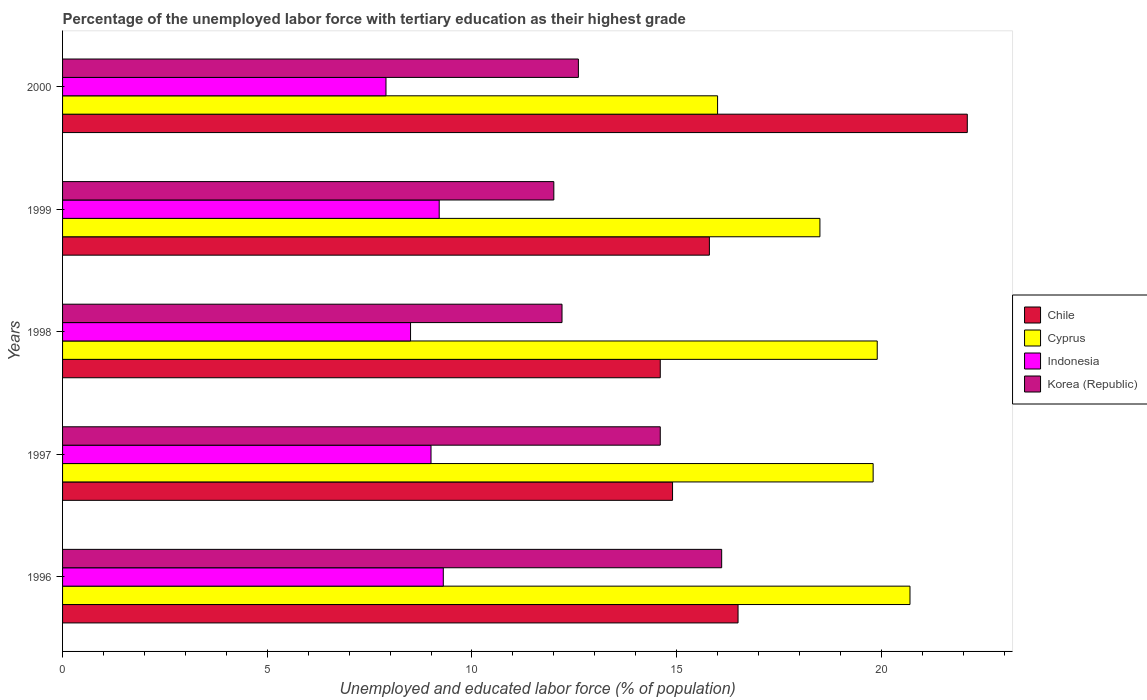How many different coloured bars are there?
Your response must be concise. 4. Are the number of bars per tick equal to the number of legend labels?
Offer a terse response. Yes. Are the number of bars on each tick of the Y-axis equal?
Offer a very short reply. Yes. How many bars are there on the 5th tick from the top?
Your answer should be compact. 4. In how many cases, is the number of bars for a given year not equal to the number of legend labels?
Offer a very short reply. 0. What is the percentage of the unemployed labor force with tertiary education in Cyprus in 1998?
Offer a very short reply. 19.9. Across all years, what is the maximum percentage of the unemployed labor force with tertiary education in Korea (Republic)?
Ensure brevity in your answer.  16.1. In which year was the percentage of the unemployed labor force with tertiary education in Korea (Republic) maximum?
Give a very brief answer. 1996. What is the total percentage of the unemployed labor force with tertiary education in Korea (Republic) in the graph?
Your answer should be very brief. 67.5. What is the difference between the percentage of the unemployed labor force with tertiary education in Indonesia in 1996 and that in 1997?
Ensure brevity in your answer.  0.3. What is the difference between the percentage of the unemployed labor force with tertiary education in Indonesia in 2000 and the percentage of the unemployed labor force with tertiary education in Chile in 1997?
Offer a terse response. -7. What is the average percentage of the unemployed labor force with tertiary education in Cyprus per year?
Keep it short and to the point. 18.98. In the year 1998, what is the difference between the percentage of the unemployed labor force with tertiary education in Korea (Republic) and percentage of the unemployed labor force with tertiary education in Chile?
Ensure brevity in your answer.  -2.4. In how many years, is the percentage of the unemployed labor force with tertiary education in Chile greater than 2 %?
Your answer should be very brief. 5. What is the ratio of the percentage of the unemployed labor force with tertiary education in Korea (Republic) in 1997 to that in 2000?
Your answer should be very brief. 1.16. Is the percentage of the unemployed labor force with tertiary education in Chile in 1996 less than that in 1999?
Make the answer very short. No. Is the difference between the percentage of the unemployed labor force with tertiary education in Korea (Republic) in 1996 and 2000 greater than the difference between the percentage of the unemployed labor force with tertiary education in Chile in 1996 and 2000?
Give a very brief answer. Yes. What is the difference between the highest and the second highest percentage of the unemployed labor force with tertiary education in Cyprus?
Make the answer very short. 0.8. What is the difference between the highest and the lowest percentage of the unemployed labor force with tertiary education in Korea (Republic)?
Your response must be concise. 4.1. In how many years, is the percentage of the unemployed labor force with tertiary education in Cyprus greater than the average percentage of the unemployed labor force with tertiary education in Cyprus taken over all years?
Offer a terse response. 3. Is the sum of the percentage of the unemployed labor force with tertiary education in Indonesia in 1999 and 2000 greater than the maximum percentage of the unemployed labor force with tertiary education in Korea (Republic) across all years?
Provide a short and direct response. Yes. Is it the case that in every year, the sum of the percentage of the unemployed labor force with tertiary education in Korea (Republic) and percentage of the unemployed labor force with tertiary education in Chile is greater than the sum of percentage of the unemployed labor force with tertiary education in Indonesia and percentage of the unemployed labor force with tertiary education in Cyprus?
Your answer should be compact. No. Is it the case that in every year, the sum of the percentage of the unemployed labor force with tertiary education in Chile and percentage of the unemployed labor force with tertiary education in Korea (Republic) is greater than the percentage of the unemployed labor force with tertiary education in Indonesia?
Give a very brief answer. Yes. How many bars are there?
Keep it short and to the point. 20. How many years are there in the graph?
Provide a short and direct response. 5. What is the difference between two consecutive major ticks on the X-axis?
Keep it short and to the point. 5. Does the graph contain grids?
Provide a succinct answer. No. Where does the legend appear in the graph?
Keep it short and to the point. Center right. What is the title of the graph?
Your answer should be compact. Percentage of the unemployed labor force with tertiary education as their highest grade. Does "Togo" appear as one of the legend labels in the graph?
Your answer should be compact. No. What is the label or title of the X-axis?
Keep it short and to the point. Unemployed and educated labor force (% of population). What is the label or title of the Y-axis?
Your answer should be compact. Years. What is the Unemployed and educated labor force (% of population) in Chile in 1996?
Your answer should be compact. 16.5. What is the Unemployed and educated labor force (% of population) in Cyprus in 1996?
Your answer should be compact. 20.7. What is the Unemployed and educated labor force (% of population) of Indonesia in 1996?
Keep it short and to the point. 9.3. What is the Unemployed and educated labor force (% of population) of Korea (Republic) in 1996?
Give a very brief answer. 16.1. What is the Unemployed and educated labor force (% of population) of Chile in 1997?
Keep it short and to the point. 14.9. What is the Unemployed and educated labor force (% of population) of Cyprus in 1997?
Keep it short and to the point. 19.8. What is the Unemployed and educated labor force (% of population) of Korea (Republic) in 1997?
Make the answer very short. 14.6. What is the Unemployed and educated labor force (% of population) of Chile in 1998?
Your answer should be compact. 14.6. What is the Unemployed and educated labor force (% of population) in Cyprus in 1998?
Your response must be concise. 19.9. What is the Unemployed and educated labor force (% of population) in Korea (Republic) in 1998?
Provide a short and direct response. 12.2. What is the Unemployed and educated labor force (% of population) of Chile in 1999?
Keep it short and to the point. 15.8. What is the Unemployed and educated labor force (% of population) of Cyprus in 1999?
Offer a very short reply. 18.5. What is the Unemployed and educated labor force (% of population) in Indonesia in 1999?
Make the answer very short. 9.2. What is the Unemployed and educated labor force (% of population) in Chile in 2000?
Your response must be concise. 22.1. What is the Unemployed and educated labor force (% of population) of Indonesia in 2000?
Make the answer very short. 7.9. What is the Unemployed and educated labor force (% of population) of Korea (Republic) in 2000?
Provide a succinct answer. 12.6. Across all years, what is the maximum Unemployed and educated labor force (% of population) in Chile?
Make the answer very short. 22.1. Across all years, what is the maximum Unemployed and educated labor force (% of population) in Cyprus?
Provide a short and direct response. 20.7. Across all years, what is the maximum Unemployed and educated labor force (% of population) of Indonesia?
Your answer should be compact. 9.3. Across all years, what is the maximum Unemployed and educated labor force (% of population) of Korea (Republic)?
Provide a short and direct response. 16.1. Across all years, what is the minimum Unemployed and educated labor force (% of population) of Chile?
Give a very brief answer. 14.6. Across all years, what is the minimum Unemployed and educated labor force (% of population) in Indonesia?
Provide a short and direct response. 7.9. What is the total Unemployed and educated labor force (% of population) in Chile in the graph?
Provide a succinct answer. 83.9. What is the total Unemployed and educated labor force (% of population) of Cyprus in the graph?
Provide a short and direct response. 94.9. What is the total Unemployed and educated labor force (% of population) of Indonesia in the graph?
Offer a terse response. 43.9. What is the total Unemployed and educated labor force (% of population) in Korea (Republic) in the graph?
Keep it short and to the point. 67.5. What is the difference between the Unemployed and educated labor force (% of population) in Indonesia in 1996 and that in 1997?
Your answer should be compact. 0.3. What is the difference between the Unemployed and educated labor force (% of population) of Korea (Republic) in 1996 and that in 1997?
Make the answer very short. 1.5. What is the difference between the Unemployed and educated labor force (% of population) in Cyprus in 1996 and that in 1998?
Keep it short and to the point. 0.8. What is the difference between the Unemployed and educated labor force (% of population) of Korea (Republic) in 1996 and that in 1998?
Offer a very short reply. 3.9. What is the difference between the Unemployed and educated labor force (% of population) of Cyprus in 1996 and that in 2000?
Your response must be concise. 4.7. What is the difference between the Unemployed and educated labor force (% of population) in Indonesia in 1996 and that in 2000?
Ensure brevity in your answer.  1.4. What is the difference between the Unemployed and educated labor force (% of population) in Cyprus in 1997 and that in 1998?
Offer a very short reply. -0.1. What is the difference between the Unemployed and educated labor force (% of population) in Korea (Republic) in 1997 and that in 1998?
Your answer should be compact. 2.4. What is the difference between the Unemployed and educated labor force (% of population) in Chile in 1997 and that in 1999?
Make the answer very short. -0.9. What is the difference between the Unemployed and educated labor force (% of population) in Cyprus in 1997 and that in 2000?
Provide a succinct answer. 3.8. What is the difference between the Unemployed and educated labor force (% of population) in Indonesia in 1997 and that in 2000?
Provide a short and direct response. 1.1. What is the difference between the Unemployed and educated labor force (% of population) of Chile in 1998 and that in 1999?
Your response must be concise. -1.2. What is the difference between the Unemployed and educated labor force (% of population) of Cyprus in 1998 and that in 1999?
Offer a very short reply. 1.4. What is the difference between the Unemployed and educated labor force (% of population) of Indonesia in 1998 and that in 1999?
Your answer should be very brief. -0.7. What is the difference between the Unemployed and educated labor force (% of population) of Korea (Republic) in 1998 and that in 1999?
Give a very brief answer. 0.2. What is the difference between the Unemployed and educated labor force (% of population) of Chile in 1998 and that in 2000?
Provide a succinct answer. -7.5. What is the difference between the Unemployed and educated labor force (% of population) in Indonesia in 1998 and that in 2000?
Offer a terse response. 0.6. What is the difference between the Unemployed and educated labor force (% of population) in Chile in 1999 and that in 2000?
Your answer should be very brief. -6.3. What is the difference between the Unemployed and educated labor force (% of population) of Cyprus in 1999 and that in 2000?
Ensure brevity in your answer.  2.5. What is the difference between the Unemployed and educated labor force (% of population) of Indonesia in 1999 and that in 2000?
Offer a terse response. 1.3. What is the difference between the Unemployed and educated labor force (% of population) of Chile in 1996 and the Unemployed and educated labor force (% of population) of Cyprus in 1997?
Give a very brief answer. -3.3. What is the difference between the Unemployed and educated labor force (% of population) in Chile in 1996 and the Unemployed and educated labor force (% of population) in Indonesia in 1997?
Your answer should be compact. 7.5. What is the difference between the Unemployed and educated labor force (% of population) of Indonesia in 1996 and the Unemployed and educated labor force (% of population) of Korea (Republic) in 1997?
Keep it short and to the point. -5.3. What is the difference between the Unemployed and educated labor force (% of population) in Chile in 1996 and the Unemployed and educated labor force (% of population) in Indonesia in 1998?
Your response must be concise. 8. What is the difference between the Unemployed and educated labor force (% of population) in Indonesia in 1996 and the Unemployed and educated labor force (% of population) in Korea (Republic) in 1998?
Your response must be concise. -2.9. What is the difference between the Unemployed and educated labor force (% of population) of Chile in 1996 and the Unemployed and educated labor force (% of population) of Indonesia in 1999?
Ensure brevity in your answer.  7.3. What is the difference between the Unemployed and educated labor force (% of population) of Cyprus in 1996 and the Unemployed and educated labor force (% of population) of Indonesia in 1999?
Your response must be concise. 11.5. What is the difference between the Unemployed and educated labor force (% of population) in Chile in 1996 and the Unemployed and educated labor force (% of population) in Indonesia in 2000?
Your response must be concise. 8.6. What is the difference between the Unemployed and educated labor force (% of population) in Chile in 1996 and the Unemployed and educated labor force (% of population) in Korea (Republic) in 2000?
Your answer should be very brief. 3.9. What is the difference between the Unemployed and educated labor force (% of population) in Cyprus in 1996 and the Unemployed and educated labor force (% of population) in Indonesia in 2000?
Keep it short and to the point. 12.8. What is the difference between the Unemployed and educated labor force (% of population) of Cyprus in 1996 and the Unemployed and educated labor force (% of population) of Korea (Republic) in 2000?
Your answer should be compact. 8.1. What is the difference between the Unemployed and educated labor force (% of population) of Chile in 1997 and the Unemployed and educated labor force (% of population) of Cyprus in 1998?
Give a very brief answer. -5. What is the difference between the Unemployed and educated labor force (% of population) in Chile in 1997 and the Unemployed and educated labor force (% of population) in Indonesia in 1998?
Provide a succinct answer. 6.4. What is the difference between the Unemployed and educated labor force (% of population) of Chile in 1997 and the Unemployed and educated labor force (% of population) of Korea (Republic) in 1998?
Ensure brevity in your answer.  2.7. What is the difference between the Unemployed and educated labor force (% of population) in Chile in 1997 and the Unemployed and educated labor force (% of population) in Cyprus in 1999?
Your response must be concise. -3.6. What is the difference between the Unemployed and educated labor force (% of population) in Indonesia in 1997 and the Unemployed and educated labor force (% of population) in Korea (Republic) in 1999?
Offer a very short reply. -3. What is the difference between the Unemployed and educated labor force (% of population) in Chile in 1997 and the Unemployed and educated labor force (% of population) in Cyprus in 2000?
Offer a very short reply. -1.1. What is the difference between the Unemployed and educated labor force (% of population) of Chile in 1997 and the Unemployed and educated labor force (% of population) of Indonesia in 2000?
Your response must be concise. 7. What is the difference between the Unemployed and educated labor force (% of population) in Chile in 1997 and the Unemployed and educated labor force (% of population) in Korea (Republic) in 2000?
Ensure brevity in your answer.  2.3. What is the difference between the Unemployed and educated labor force (% of population) of Cyprus in 1997 and the Unemployed and educated labor force (% of population) of Korea (Republic) in 2000?
Offer a very short reply. 7.2. What is the difference between the Unemployed and educated labor force (% of population) in Indonesia in 1997 and the Unemployed and educated labor force (% of population) in Korea (Republic) in 2000?
Keep it short and to the point. -3.6. What is the difference between the Unemployed and educated labor force (% of population) in Chile in 1998 and the Unemployed and educated labor force (% of population) in Cyprus in 1999?
Your answer should be very brief. -3.9. What is the difference between the Unemployed and educated labor force (% of population) of Chile in 1998 and the Unemployed and educated labor force (% of population) of Korea (Republic) in 1999?
Your response must be concise. 2.6. What is the difference between the Unemployed and educated labor force (% of population) in Cyprus in 1998 and the Unemployed and educated labor force (% of population) in Korea (Republic) in 1999?
Make the answer very short. 7.9. What is the difference between the Unemployed and educated labor force (% of population) in Indonesia in 1998 and the Unemployed and educated labor force (% of population) in Korea (Republic) in 1999?
Keep it short and to the point. -3.5. What is the difference between the Unemployed and educated labor force (% of population) in Chile in 1998 and the Unemployed and educated labor force (% of population) in Cyprus in 2000?
Offer a terse response. -1.4. What is the difference between the Unemployed and educated labor force (% of population) in Cyprus in 1998 and the Unemployed and educated labor force (% of population) in Indonesia in 2000?
Ensure brevity in your answer.  12. What is the difference between the Unemployed and educated labor force (% of population) in Cyprus in 1999 and the Unemployed and educated labor force (% of population) in Indonesia in 2000?
Your response must be concise. 10.6. What is the average Unemployed and educated labor force (% of population) in Chile per year?
Keep it short and to the point. 16.78. What is the average Unemployed and educated labor force (% of population) of Cyprus per year?
Offer a terse response. 18.98. What is the average Unemployed and educated labor force (% of population) in Indonesia per year?
Offer a very short reply. 8.78. What is the average Unemployed and educated labor force (% of population) of Korea (Republic) per year?
Your response must be concise. 13.5. In the year 1996, what is the difference between the Unemployed and educated labor force (% of population) of Chile and Unemployed and educated labor force (% of population) of Indonesia?
Ensure brevity in your answer.  7.2. In the year 1996, what is the difference between the Unemployed and educated labor force (% of population) of Chile and Unemployed and educated labor force (% of population) of Korea (Republic)?
Offer a terse response. 0.4. In the year 1996, what is the difference between the Unemployed and educated labor force (% of population) in Cyprus and Unemployed and educated labor force (% of population) in Indonesia?
Keep it short and to the point. 11.4. In the year 1996, what is the difference between the Unemployed and educated labor force (% of population) in Indonesia and Unemployed and educated labor force (% of population) in Korea (Republic)?
Provide a short and direct response. -6.8. In the year 1997, what is the difference between the Unemployed and educated labor force (% of population) of Chile and Unemployed and educated labor force (% of population) of Cyprus?
Provide a short and direct response. -4.9. In the year 1997, what is the difference between the Unemployed and educated labor force (% of population) in Chile and Unemployed and educated labor force (% of population) in Indonesia?
Offer a very short reply. 5.9. In the year 1997, what is the difference between the Unemployed and educated labor force (% of population) in Chile and Unemployed and educated labor force (% of population) in Korea (Republic)?
Keep it short and to the point. 0.3. In the year 1997, what is the difference between the Unemployed and educated labor force (% of population) in Cyprus and Unemployed and educated labor force (% of population) in Korea (Republic)?
Provide a short and direct response. 5.2. In the year 1997, what is the difference between the Unemployed and educated labor force (% of population) in Indonesia and Unemployed and educated labor force (% of population) in Korea (Republic)?
Your response must be concise. -5.6. In the year 1998, what is the difference between the Unemployed and educated labor force (% of population) of Chile and Unemployed and educated labor force (% of population) of Indonesia?
Give a very brief answer. 6.1. In the year 1998, what is the difference between the Unemployed and educated labor force (% of population) in Cyprus and Unemployed and educated labor force (% of population) in Indonesia?
Make the answer very short. 11.4. In the year 1999, what is the difference between the Unemployed and educated labor force (% of population) of Cyprus and Unemployed and educated labor force (% of population) of Korea (Republic)?
Give a very brief answer. 6.5. In the year 1999, what is the difference between the Unemployed and educated labor force (% of population) of Indonesia and Unemployed and educated labor force (% of population) of Korea (Republic)?
Offer a terse response. -2.8. In the year 2000, what is the difference between the Unemployed and educated labor force (% of population) of Chile and Unemployed and educated labor force (% of population) of Cyprus?
Give a very brief answer. 6.1. In the year 2000, what is the difference between the Unemployed and educated labor force (% of population) of Chile and Unemployed and educated labor force (% of population) of Korea (Republic)?
Keep it short and to the point. 9.5. What is the ratio of the Unemployed and educated labor force (% of population) in Chile in 1996 to that in 1997?
Give a very brief answer. 1.11. What is the ratio of the Unemployed and educated labor force (% of population) of Cyprus in 1996 to that in 1997?
Your answer should be very brief. 1.05. What is the ratio of the Unemployed and educated labor force (% of population) in Korea (Republic) in 1996 to that in 1997?
Give a very brief answer. 1.1. What is the ratio of the Unemployed and educated labor force (% of population) in Chile in 1996 to that in 1998?
Your response must be concise. 1.13. What is the ratio of the Unemployed and educated labor force (% of population) of Cyprus in 1996 to that in 1998?
Make the answer very short. 1.04. What is the ratio of the Unemployed and educated labor force (% of population) in Indonesia in 1996 to that in 1998?
Your response must be concise. 1.09. What is the ratio of the Unemployed and educated labor force (% of population) of Korea (Republic) in 1996 to that in 1998?
Offer a very short reply. 1.32. What is the ratio of the Unemployed and educated labor force (% of population) in Chile in 1996 to that in 1999?
Ensure brevity in your answer.  1.04. What is the ratio of the Unemployed and educated labor force (% of population) of Cyprus in 1996 to that in 1999?
Offer a very short reply. 1.12. What is the ratio of the Unemployed and educated labor force (% of population) of Indonesia in 1996 to that in 1999?
Your response must be concise. 1.01. What is the ratio of the Unemployed and educated labor force (% of population) in Korea (Republic) in 1996 to that in 1999?
Offer a very short reply. 1.34. What is the ratio of the Unemployed and educated labor force (% of population) of Chile in 1996 to that in 2000?
Offer a very short reply. 0.75. What is the ratio of the Unemployed and educated labor force (% of population) in Cyprus in 1996 to that in 2000?
Make the answer very short. 1.29. What is the ratio of the Unemployed and educated labor force (% of population) of Indonesia in 1996 to that in 2000?
Your response must be concise. 1.18. What is the ratio of the Unemployed and educated labor force (% of population) in Korea (Republic) in 1996 to that in 2000?
Your response must be concise. 1.28. What is the ratio of the Unemployed and educated labor force (% of population) of Chile in 1997 to that in 1998?
Provide a succinct answer. 1.02. What is the ratio of the Unemployed and educated labor force (% of population) of Cyprus in 1997 to that in 1998?
Give a very brief answer. 0.99. What is the ratio of the Unemployed and educated labor force (% of population) of Indonesia in 1997 to that in 1998?
Offer a terse response. 1.06. What is the ratio of the Unemployed and educated labor force (% of population) of Korea (Republic) in 1997 to that in 1998?
Offer a very short reply. 1.2. What is the ratio of the Unemployed and educated labor force (% of population) of Chile in 1997 to that in 1999?
Ensure brevity in your answer.  0.94. What is the ratio of the Unemployed and educated labor force (% of population) in Cyprus in 1997 to that in 1999?
Your response must be concise. 1.07. What is the ratio of the Unemployed and educated labor force (% of population) in Indonesia in 1997 to that in 1999?
Your answer should be compact. 0.98. What is the ratio of the Unemployed and educated labor force (% of population) of Korea (Republic) in 1997 to that in 1999?
Give a very brief answer. 1.22. What is the ratio of the Unemployed and educated labor force (% of population) of Chile in 1997 to that in 2000?
Provide a succinct answer. 0.67. What is the ratio of the Unemployed and educated labor force (% of population) of Cyprus in 1997 to that in 2000?
Your response must be concise. 1.24. What is the ratio of the Unemployed and educated labor force (% of population) of Indonesia in 1997 to that in 2000?
Your answer should be very brief. 1.14. What is the ratio of the Unemployed and educated labor force (% of population) of Korea (Republic) in 1997 to that in 2000?
Your answer should be very brief. 1.16. What is the ratio of the Unemployed and educated labor force (% of population) in Chile in 1998 to that in 1999?
Give a very brief answer. 0.92. What is the ratio of the Unemployed and educated labor force (% of population) of Cyprus in 1998 to that in 1999?
Ensure brevity in your answer.  1.08. What is the ratio of the Unemployed and educated labor force (% of population) in Indonesia in 1998 to that in 1999?
Make the answer very short. 0.92. What is the ratio of the Unemployed and educated labor force (% of population) in Korea (Republic) in 1998 to that in 1999?
Give a very brief answer. 1.02. What is the ratio of the Unemployed and educated labor force (% of population) in Chile in 1998 to that in 2000?
Your answer should be very brief. 0.66. What is the ratio of the Unemployed and educated labor force (% of population) in Cyprus in 1998 to that in 2000?
Provide a succinct answer. 1.24. What is the ratio of the Unemployed and educated labor force (% of population) in Indonesia in 1998 to that in 2000?
Your answer should be compact. 1.08. What is the ratio of the Unemployed and educated labor force (% of population) in Korea (Republic) in 1998 to that in 2000?
Provide a short and direct response. 0.97. What is the ratio of the Unemployed and educated labor force (% of population) of Chile in 1999 to that in 2000?
Provide a succinct answer. 0.71. What is the ratio of the Unemployed and educated labor force (% of population) of Cyprus in 1999 to that in 2000?
Keep it short and to the point. 1.16. What is the ratio of the Unemployed and educated labor force (% of population) of Indonesia in 1999 to that in 2000?
Make the answer very short. 1.16. What is the ratio of the Unemployed and educated labor force (% of population) in Korea (Republic) in 1999 to that in 2000?
Your answer should be compact. 0.95. What is the difference between the highest and the second highest Unemployed and educated labor force (% of population) of Cyprus?
Your answer should be very brief. 0.8. What is the difference between the highest and the second highest Unemployed and educated labor force (% of population) of Indonesia?
Make the answer very short. 0.1. What is the difference between the highest and the lowest Unemployed and educated labor force (% of population) of Chile?
Keep it short and to the point. 7.5. What is the difference between the highest and the lowest Unemployed and educated labor force (% of population) in Cyprus?
Provide a succinct answer. 4.7. What is the difference between the highest and the lowest Unemployed and educated labor force (% of population) of Indonesia?
Make the answer very short. 1.4. 